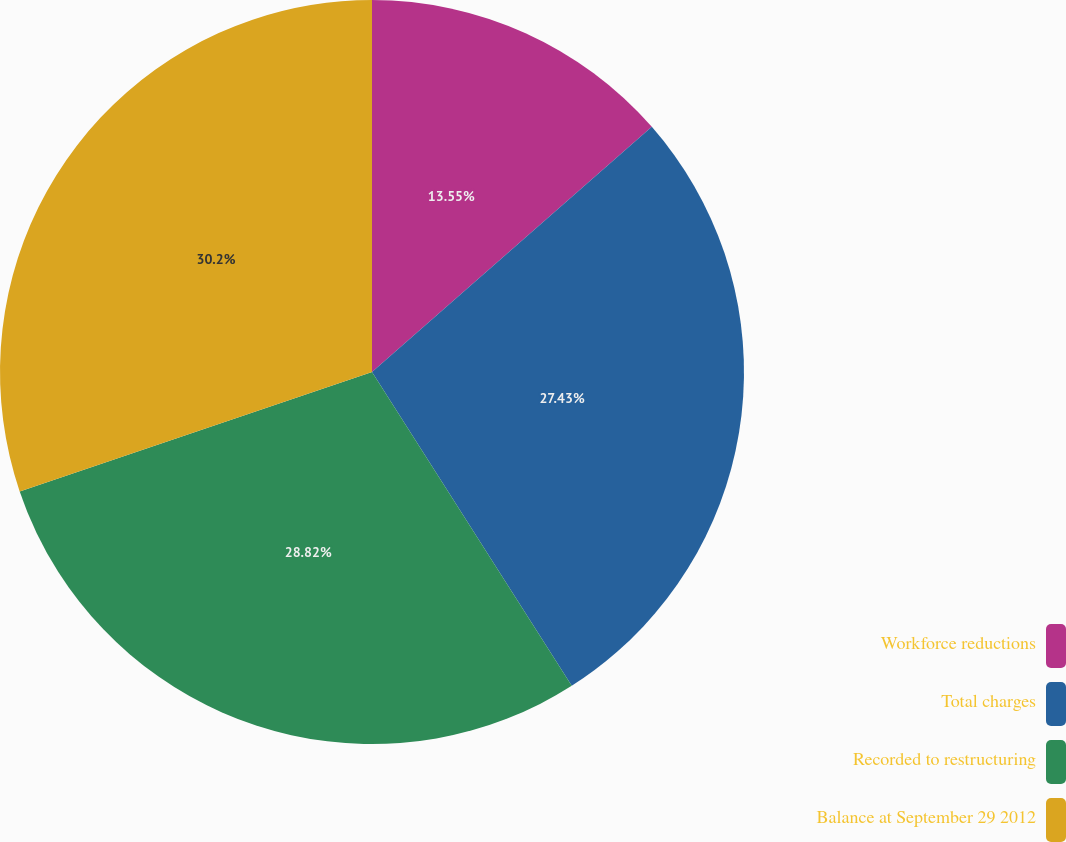<chart> <loc_0><loc_0><loc_500><loc_500><pie_chart><fcel>Workforce reductions<fcel>Total charges<fcel>Recorded to restructuring<fcel>Balance at September 29 2012<nl><fcel>13.55%<fcel>27.43%<fcel>28.82%<fcel>30.2%<nl></chart> 